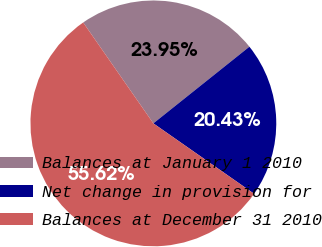Convert chart. <chart><loc_0><loc_0><loc_500><loc_500><pie_chart><fcel>Balances at January 1 2010<fcel>Net change in provision for<fcel>Balances at December 31 2010<nl><fcel>23.95%<fcel>20.43%<fcel>55.62%<nl></chart> 